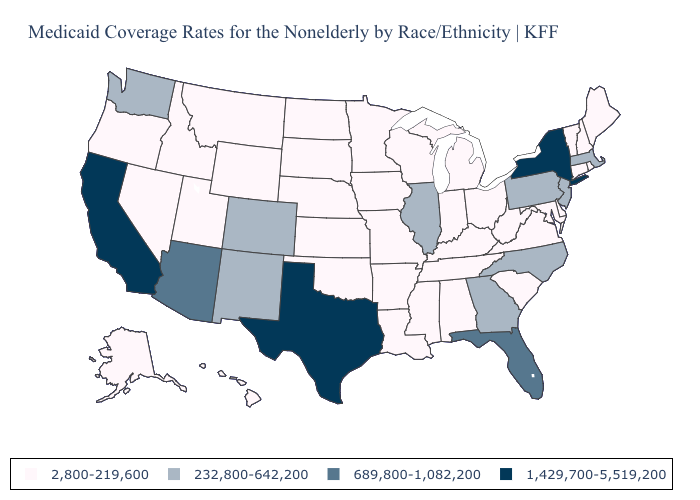What is the lowest value in the MidWest?
Concise answer only. 2,800-219,600. What is the value of West Virginia?
Quick response, please. 2,800-219,600. What is the value of Oklahoma?
Write a very short answer. 2,800-219,600. Does California have the highest value in the USA?
Keep it brief. Yes. Does Texas have the highest value in the South?
Give a very brief answer. Yes. What is the lowest value in states that border Colorado?
Short answer required. 2,800-219,600. What is the value of Montana?
Be succinct. 2,800-219,600. Which states hav the highest value in the West?
Keep it brief. California. Does Wyoming have the highest value in the West?
Answer briefly. No. What is the lowest value in the South?
Be succinct. 2,800-219,600. Which states have the lowest value in the USA?
Quick response, please. Alabama, Alaska, Arkansas, Connecticut, Delaware, Hawaii, Idaho, Indiana, Iowa, Kansas, Kentucky, Louisiana, Maine, Maryland, Michigan, Minnesota, Mississippi, Missouri, Montana, Nebraska, Nevada, New Hampshire, North Dakota, Ohio, Oklahoma, Oregon, Rhode Island, South Carolina, South Dakota, Tennessee, Utah, Vermont, Virginia, West Virginia, Wisconsin, Wyoming. What is the value of Pennsylvania?
Keep it brief. 232,800-642,200. Name the states that have a value in the range 689,800-1,082,200?
Write a very short answer. Arizona, Florida. What is the lowest value in states that border Missouri?
Write a very short answer. 2,800-219,600. Is the legend a continuous bar?
Be succinct. No. 